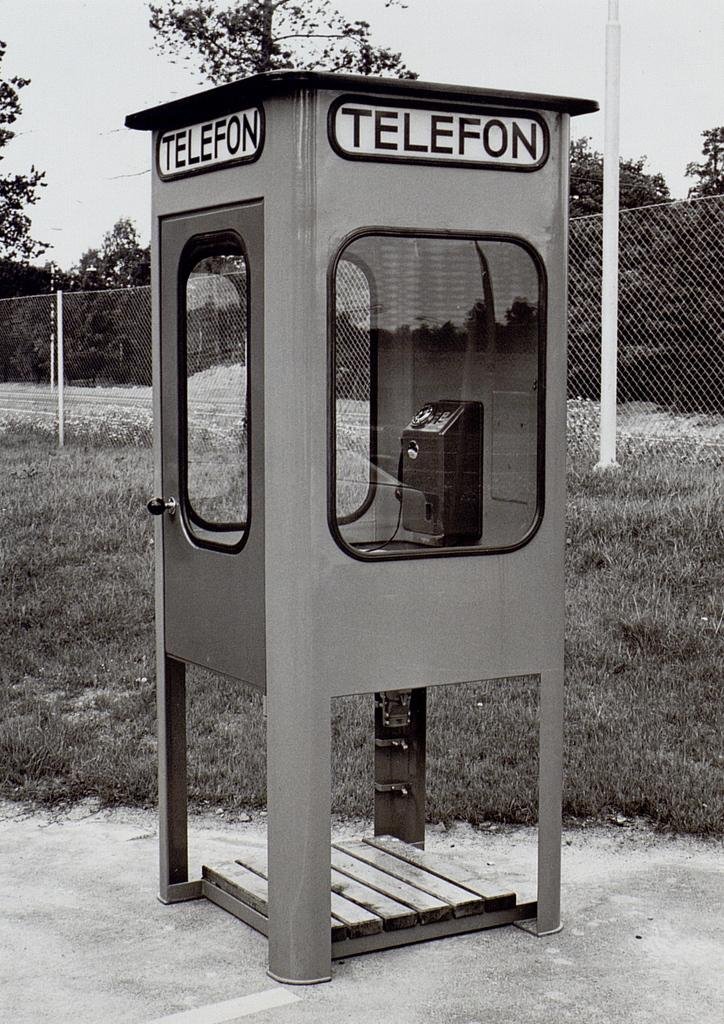<image>
Share a concise interpretation of the image provided. A very old phone booth with the word Telefon on it is in front of a tall, metal fence. 